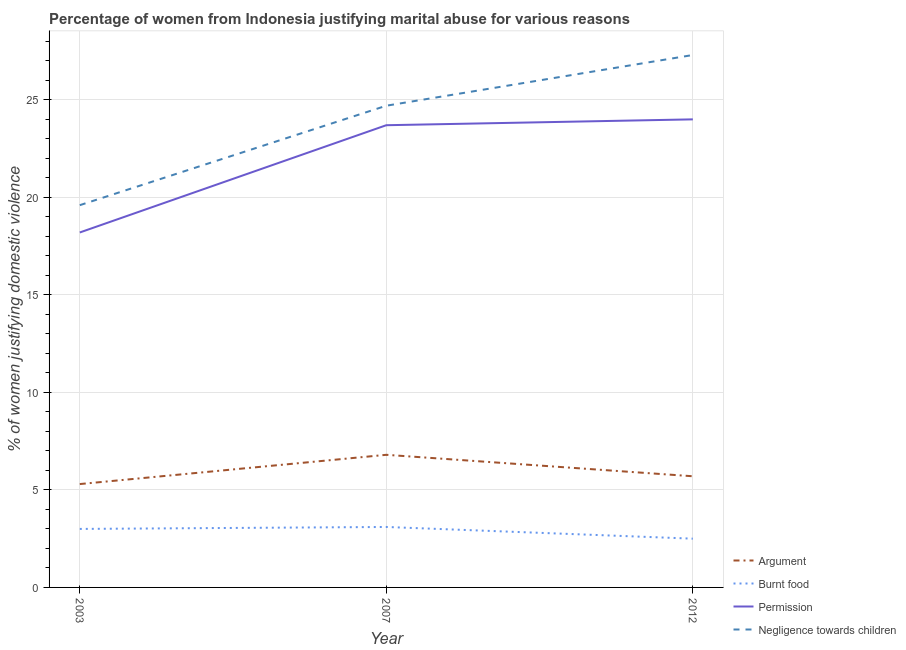Is the number of lines equal to the number of legend labels?
Your response must be concise. Yes. Across all years, what is the maximum percentage of women justifying abuse for going without permission?
Give a very brief answer. 24. In which year was the percentage of women justifying abuse for burning food minimum?
Provide a short and direct response. 2012. What is the difference between the percentage of women justifying abuse in the case of an argument in 2007 and the percentage of women justifying abuse for going without permission in 2003?
Your answer should be very brief. -11.4. What is the average percentage of women justifying abuse for going without permission per year?
Your response must be concise. 21.97. In the year 2012, what is the difference between the percentage of women justifying abuse for going without permission and percentage of women justifying abuse for showing negligence towards children?
Provide a short and direct response. -3.3. What is the ratio of the percentage of women justifying abuse in the case of an argument in 2007 to that in 2012?
Give a very brief answer. 1.19. Is the percentage of women justifying abuse for burning food in 2003 less than that in 2007?
Make the answer very short. Yes. Is the difference between the percentage of women justifying abuse in the case of an argument in 2003 and 2007 greater than the difference between the percentage of women justifying abuse for going without permission in 2003 and 2007?
Your answer should be very brief. Yes. What is the difference between the highest and the second highest percentage of women justifying abuse for showing negligence towards children?
Offer a very short reply. 2.6. What is the difference between the highest and the lowest percentage of women justifying abuse for showing negligence towards children?
Your answer should be compact. 7.7. In how many years, is the percentage of women justifying abuse for burning food greater than the average percentage of women justifying abuse for burning food taken over all years?
Ensure brevity in your answer.  2. Is it the case that in every year, the sum of the percentage of women justifying abuse for going without permission and percentage of women justifying abuse in the case of an argument is greater than the sum of percentage of women justifying abuse for burning food and percentage of women justifying abuse for showing negligence towards children?
Your answer should be very brief. No. Is it the case that in every year, the sum of the percentage of women justifying abuse in the case of an argument and percentage of women justifying abuse for burning food is greater than the percentage of women justifying abuse for going without permission?
Provide a short and direct response. No. Is the percentage of women justifying abuse in the case of an argument strictly greater than the percentage of women justifying abuse for burning food over the years?
Keep it short and to the point. Yes. Is the percentage of women justifying abuse for showing negligence towards children strictly less than the percentage of women justifying abuse for going without permission over the years?
Your answer should be very brief. No. How many lines are there?
Offer a very short reply. 4. Are the values on the major ticks of Y-axis written in scientific E-notation?
Offer a terse response. No. Does the graph contain any zero values?
Your answer should be very brief. No. Does the graph contain grids?
Provide a short and direct response. Yes. What is the title of the graph?
Provide a succinct answer. Percentage of women from Indonesia justifying marital abuse for various reasons. Does "Korea" appear as one of the legend labels in the graph?
Offer a very short reply. No. What is the label or title of the Y-axis?
Make the answer very short. % of women justifying domestic violence. What is the % of women justifying domestic violence in Burnt food in 2003?
Your response must be concise. 3. What is the % of women justifying domestic violence of Negligence towards children in 2003?
Provide a succinct answer. 19.6. What is the % of women justifying domestic violence in Argument in 2007?
Offer a very short reply. 6.8. What is the % of women justifying domestic violence in Permission in 2007?
Ensure brevity in your answer.  23.7. What is the % of women justifying domestic violence in Negligence towards children in 2007?
Ensure brevity in your answer.  24.7. What is the % of women justifying domestic violence in Argument in 2012?
Offer a terse response. 5.7. What is the % of women justifying domestic violence in Negligence towards children in 2012?
Give a very brief answer. 27.3. Across all years, what is the maximum % of women justifying domestic violence in Permission?
Offer a very short reply. 24. Across all years, what is the maximum % of women justifying domestic violence in Negligence towards children?
Keep it short and to the point. 27.3. Across all years, what is the minimum % of women justifying domestic violence in Argument?
Make the answer very short. 5.3. Across all years, what is the minimum % of women justifying domestic violence of Burnt food?
Give a very brief answer. 2.5. Across all years, what is the minimum % of women justifying domestic violence in Negligence towards children?
Your response must be concise. 19.6. What is the total % of women justifying domestic violence in Argument in the graph?
Ensure brevity in your answer.  17.8. What is the total % of women justifying domestic violence of Permission in the graph?
Give a very brief answer. 65.9. What is the total % of women justifying domestic violence in Negligence towards children in the graph?
Ensure brevity in your answer.  71.6. What is the difference between the % of women justifying domestic violence of Burnt food in 2003 and that in 2007?
Your answer should be compact. -0.1. What is the difference between the % of women justifying domestic violence of Permission in 2003 and that in 2007?
Offer a terse response. -5.5. What is the difference between the % of women justifying domestic violence in Negligence towards children in 2003 and that in 2007?
Your response must be concise. -5.1. What is the difference between the % of women justifying domestic violence of Burnt food in 2003 and that in 2012?
Offer a very short reply. 0.5. What is the difference between the % of women justifying domestic violence of Permission in 2003 and that in 2012?
Provide a succinct answer. -5.8. What is the difference between the % of women justifying domestic violence of Negligence towards children in 2003 and that in 2012?
Your answer should be compact. -7.7. What is the difference between the % of women justifying domestic violence in Negligence towards children in 2007 and that in 2012?
Your answer should be very brief. -2.6. What is the difference between the % of women justifying domestic violence in Argument in 2003 and the % of women justifying domestic violence in Burnt food in 2007?
Your response must be concise. 2.2. What is the difference between the % of women justifying domestic violence of Argument in 2003 and the % of women justifying domestic violence of Permission in 2007?
Offer a terse response. -18.4. What is the difference between the % of women justifying domestic violence of Argument in 2003 and the % of women justifying domestic violence of Negligence towards children in 2007?
Your answer should be compact. -19.4. What is the difference between the % of women justifying domestic violence of Burnt food in 2003 and the % of women justifying domestic violence of Permission in 2007?
Provide a succinct answer. -20.7. What is the difference between the % of women justifying domestic violence of Burnt food in 2003 and the % of women justifying domestic violence of Negligence towards children in 2007?
Your response must be concise. -21.7. What is the difference between the % of women justifying domestic violence of Permission in 2003 and the % of women justifying domestic violence of Negligence towards children in 2007?
Give a very brief answer. -6.5. What is the difference between the % of women justifying domestic violence in Argument in 2003 and the % of women justifying domestic violence in Burnt food in 2012?
Your answer should be compact. 2.8. What is the difference between the % of women justifying domestic violence of Argument in 2003 and the % of women justifying domestic violence of Permission in 2012?
Keep it short and to the point. -18.7. What is the difference between the % of women justifying domestic violence of Argument in 2003 and the % of women justifying domestic violence of Negligence towards children in 2012?
Keep it short and to the point. -22. What is the difference between the % of women justifying domestic violence of Burnt food in 2003 and the % of women justifying domestic violence of Permission in 2012?
Provide a short and direct response. -21. What is the difference between the % of women justifying domestic violence of Burnt food in 2003 and the % of women justifying domestic violence of Negligence towards children in 2012?
Keep it short and to the point. -24.3. What is the difference between the % of women justifying domestic violence of Permission in 2003 and the % of women justifying domestic violence of Negligence towards children in 2012?
Your answer should be very brief. -9.1. What is the difference between the % of women justifying domestic violence of Argument in 2007 and the % of women justifying domestic violence of Burnt food in 2012?
Your response must be concise. 4.3. What is the difference between the % of women justifying domestic violence in Argument in 2007 and the % of women justifying domestic violence in Permission in 2012?
Give a very brief answer. -17.2. What is the difference between the % of women justifying domestic violence in Argument in 2007 and the % of women justifying domestic violence in Negligence towards children in 2012?
Provide a short and direct response. -20.5. What is the difference between the % of women justifying domestic violence in Burnt food in 2007 and the % of women justifying domestic violence in Permission in 2012?
Your answer should be very brief. -20.9. What is the difference between the % of women justifying domestic violence of Burnt food in 2007 and the % of women justifying domestic violence of Negligence towards children in 2012?
Offer a very short reply. -24.2. What is the difference between the % of women justifying domestic violence of Permission in 2007 and the % of women justifying domestic violence of Negligence towards children in 2012?
Provide a succinct answer. -3.6. What is the average % of women justifying domestic violence in Argument per year?
Your answer should be compact. 5.93. What is the average % of women justifying domestic violence in Burnt food per year?
Ensure brevity in your answer.  2.87. What is the average % of women justifying domestic violence in Permission per year?
Your answer should be very brief. 21.97. What is the average % of women justifying domestic violence of Negligence towards children per year?
Keep it short and to the point. 23.87. In the year 2003, what is the difference between the % of women justifying domestic violence of Argument and % of women justifying domestic violence of Burnt food?
Offer a terse response. 2.3. In the year 2003, what is the difference between the % of women justifying domestic violence in Argument and % of women justifying domestic violence in Permission?
Offer a terse response. -12.9. In the year 2003, what is the difference between the % of women justifying domestic violence in Argument and % of women justifying domestic violence in Negligence towards children?
Offer a terse response. -14.3. In the year 2003, what is the difference between the % of women justifying domestic violence in Burnt food and % of women justifying domestic violence in Permission?
Ensure brevity in your answer.  -15.2. In the year 2003, what is the difference between the % of women justifying domestic violence of Burnt food and % of women justifying domestic violence of Negligence towards children?
Your answer should be compact. -16.6. In the year 2003, what is the difference between the % of women justifying domestic violence in Permission and % of women justifying domestic violence in Negligence towards children?
Keep it short and to the point. -1.4. In the year 2007, what is the difference between the % of women justifying domestic violence of Argument and % of women justifying domestic violence of Permission?
Your answer should be compact. -16.9. In the year 2007, what is the difference between the % of women justifying domestic violence of Argument and % of women justifying domestic violence of Negligence towards children?
Provide a short and direct response. -17.9. In the year 2007, what is the difference between the % of women justifying domestic violence in Burnt food and % of women justifying domestic violence in Permission?
Ensure brevity in your answer.  -20.6. In the year 2007, what is the difference between the % of women justifying domestic violence in Burnt food and % of women justifying domestic violence in Negligence towards children?
Provide a short and direct response. -21.6. In the year 2007, what is the difference between the % of women justifying domestic violence in Permission and % of women justifying domestic violence in Negligence towards children?
Provide a short and direct response. -1. In the year 2012, what is the difference between the % of women justifying domestic violence in Argument and % of women justifying domestic violence in Permission?
Offer a very short reply. -18.3. In the year 2012, what is the difference between the % of women justifying domestic violence in Argument and % of women justifying domestic violence in Negligence towards children?
Provide a succinct answer. -21.6. In the year 2012, what is the difference between the % of women justifying domestic violence of Burnt food and % of women justifying domestic violence of Permission?
Ensure brevity in your answer.  -21.5. In the year 2012, what is the difference between the % of women justifying domestic violence in Burnt food and % of women justifying domestic violence in Negligence towards children?
Make the answer very short. -24.8. What is the ratio of the % of women justifying domestic violence of Argument in 2003 to that in 2007?
Make the answer very short. 0.78. What is the ratio of the % of women justifying domestic violence in Permission in 2003 to that in 2007?
Your response must be concise. 0.77. What is the ratio of the % of women justifying domestic violence in Negligence towards children in 2003 to that in 2007?
Give a very brief answer. 0.79. What is the ratio of the % of women justifying domestic violence of Argument in 2003 to that in 2012?
Provide a short and direct response. 0.93. What is the ratio of the % of women justifying domestic violence of Burnt food in 2003 to that in 2012?
Your response must be concise. 1.2. What is the ratio of the % of women justifying domestic violence in Permission in 2003 to that in 2012?
Provide a succinct answer. 0.76. What is the ratio of the % of women justifying domestic violence of Negligence towards children in 2003 to that in 2012?
Provide a succinct answer. 0.72. What is the ratio of the % of women justifying domestic violence in Argument in 2007 to that in 2012?
Your answer should be compact. 1.19. What is the ratio of the % of women justifying domestic violence of Burnt food in 2007 to that in 2012?
Your answer should be compact. 1.24. What is the ratio of the % of women justifying domestic violence in Permission in 2007 to that in 2012?
Make the answer very short. 0.99. What is the ratio of the % of women justifying domestic violence of Negligence towards children in 2007 to that in 2012?
Offer a terse response. 0.9. What is the difference between the highest and the second highest % of women justifying domestic violence in Argument?
Offer a terse response. 1.1. What is the difference between the highest and the second highest % of women justifying domestic violence of Permission?
Give a very brief answer. 0.3. What is the difference between the highest and the second highest % of women justifying domestic violence in Negligence towards children?
Your answer should be very brief. 2.6. What is the difference between the highest and the lowest % of women justifying domestic violence of Permission?
Make the answer very short. 5.8. 